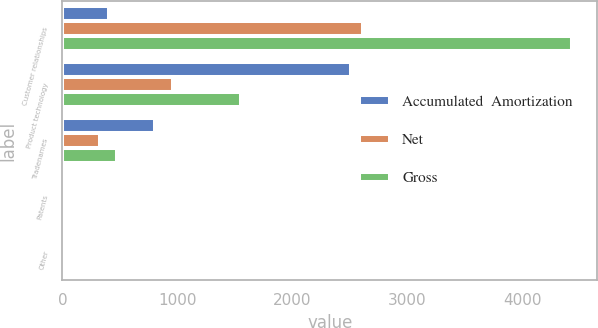Convert chart. <chart><loc_0><loc_0><loc_500><loc_500><stacked_bar_chart><ecel><fcel>Customer relationships<fcel>Product technology<fcel>Tradenames<fcel>Patents<fcel>Other<nl><fcel>Accumulated  Amortization<fcel>403.9<fcel>2512.9<fcel>807.8<fcel>19.7<fcel>15.7<nl><fcel>Net<fcel>2617.6<fcel>958.6<fcel>330.5<fcel>19.2<fcel>13.3<nl><fcel>Gross<fcel>4429.4<fcel>1554.3<fcel>477.3<fcel>0.5<fcel>2.4<nl></chart> 